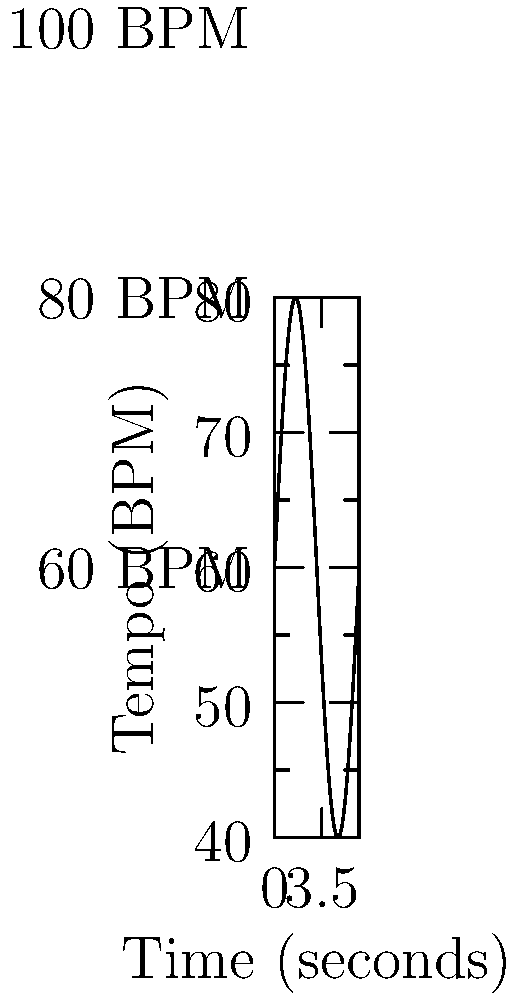As a competitive drummer preparing for a scholarship audition, you encounter a graphical metronome display during a practice session. The graph shows tempo changes over time. If you start playing at the beginning of this cycle, at what point in seconds will you reach the fastest tempo? To determine when the fastest tempo occurs, we need to analyze the given graph:

1. The graph represents tempo changes over time, with the x-axis showing time in seconds and the y-axis showing tempo in beats per minute (BPM).

2. The tempo oscillates between 60 BPM and 100 BPM, following a sine wave pattern.

3. In a sine wave, the maximum point (peak) represents the fastest tempo.

4. The graph shows one complete cycle of the sine wave, which corresponds to $2\pi$ seconds.

5. For a standard sine wave, the peak occurs at $\frac{\pi}{2}$ radians or one-quarter of the full cycle.

6. Since the full cycle is $2\pi$ seconds, we can calculate the time to reach the peak:

   Time to peak = $\frac{2\pi}{4} = \frac{\pi}{2}$ seconds

7. Converting this to a decimal:
   $\frac{\pi}{2} \approx 1.57$ seconds

Therefore, you will reach the fastest tempo approximately 1.57 seconds after starting to play.
Answer: $\frac{\pi}{2}$ seconds 